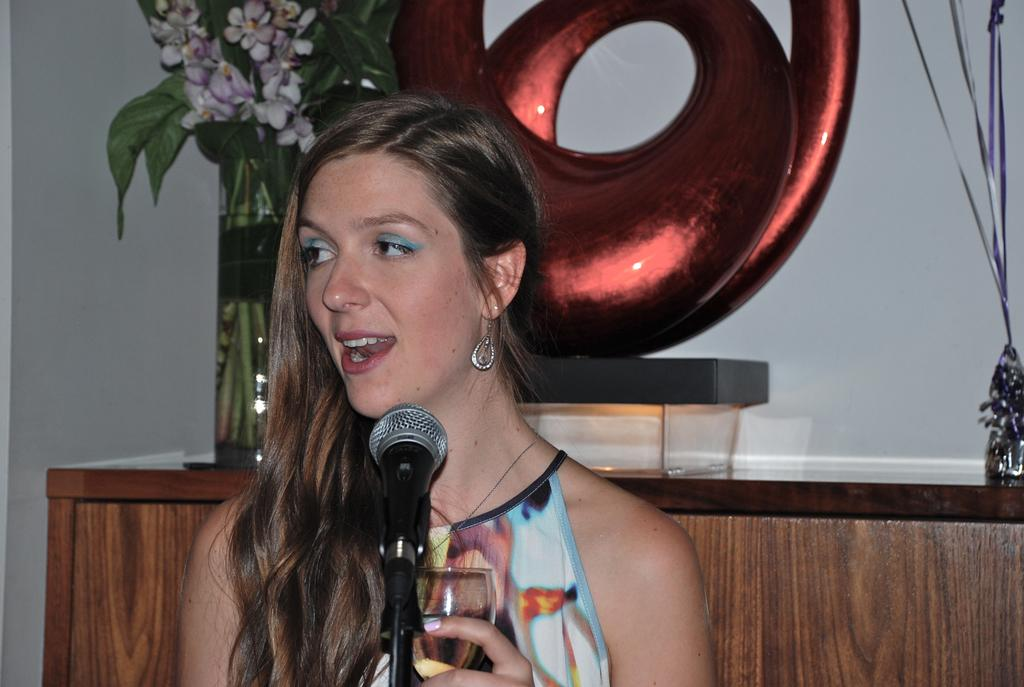What is the woman in the image doing? The woman is seated and speaking using a microphone. What is the woman holding in her hand? The woman is holding a wine glass in her hand. What can be seen on the table in the image? There is a flower vase on the table. How many cans are visible in the image? There are no cans present in the image. What color is the woman's eye in the image? The provided facts do not mention the color of the woman's eye, so it cannot be determined from the image. 